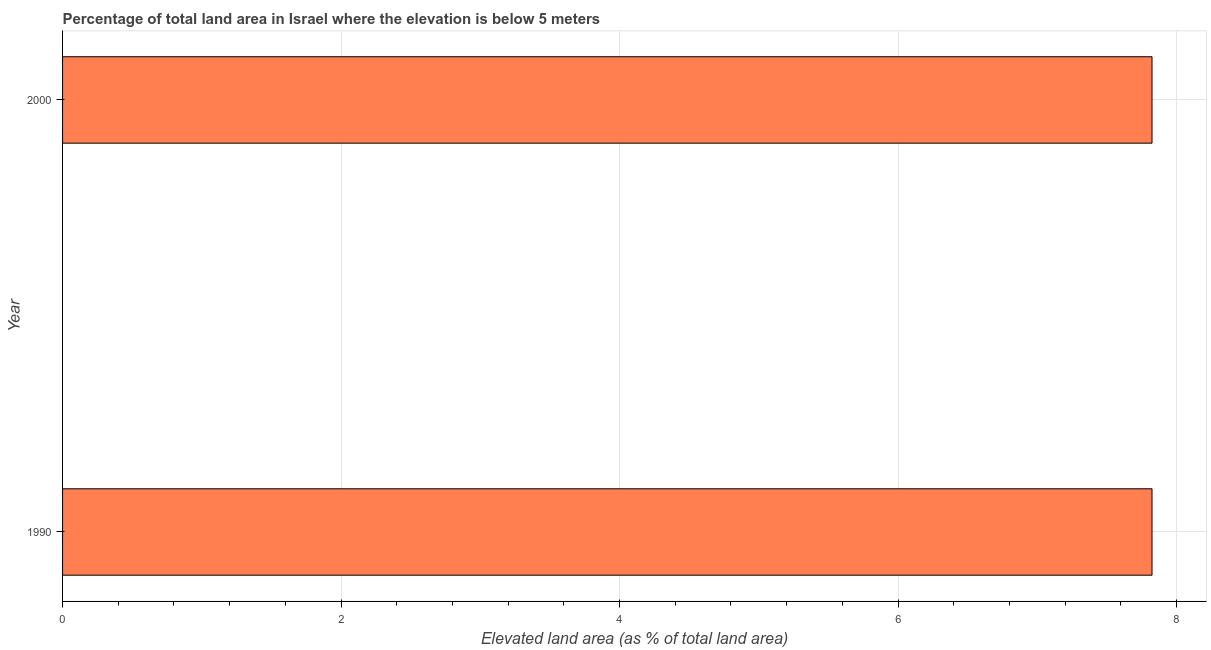Does the graph contain grids?
Make the answer very short. Yes. What is the title of the graph?
Make the answer very short. Percentage of total land area in Israel where the elevation is below 5 meters. What is the label or title of the X-axis?
Offer a terse response. Elevated land area (as % of total land area). What is the label or title of the Y-axis?
Offer a terse response. Year. What is the total elevated land area in 2000?
Make the answer very short. 7.82. Across all years, what is the maximum total elevated land area?
Your answer should be compact. 7.82. Across all years, what is the minimum total elevated land area?
Provide a succinct answer. 7.82. In which year was the total elevated land area minimum?
Offer a terse response. 1990. What is the sum of the total elevated land area?
Ensure brevity in your answer.  15.65. What is the difference between the total elevated land area in 1990 and 2000?
Keep it short and to the point. 0. What is the average total elevated land area per year?
Your answer should be very brief. 7.82. What is the median total elevated land area?
Keep it short and to the point. 7.82. Is the total elevated land area in 1990 less than that in 2000?
Give a very brief answer. No. In how many years, is the total elevated land area greater than the average total elevated land area taken over all years?
Provide a succinct answer. 0. Are all the bars in the graph horizontal?
Ensure brevity in your answer.  Yes. How many years are there in the graph?
Provide a succinct answer. 2. What is the difference between two consecutive major ticks on the X-axis?
Offer a terse response. 2. Are the values on the major ticks of X-axis written in scientific E-notation?
Provide a succinct answer. No. What is the Elevated land area (as % of total land area) of 1990?
Provide a succinct answer. 7.82. What is the Elevated land area (as % of total land area) of 2000?
Offer a terse response. 7.82. What is the ratio of the Elevated land area (as % of total land area) in 1990 to that in 2000?
Make the answer very short. 1. 